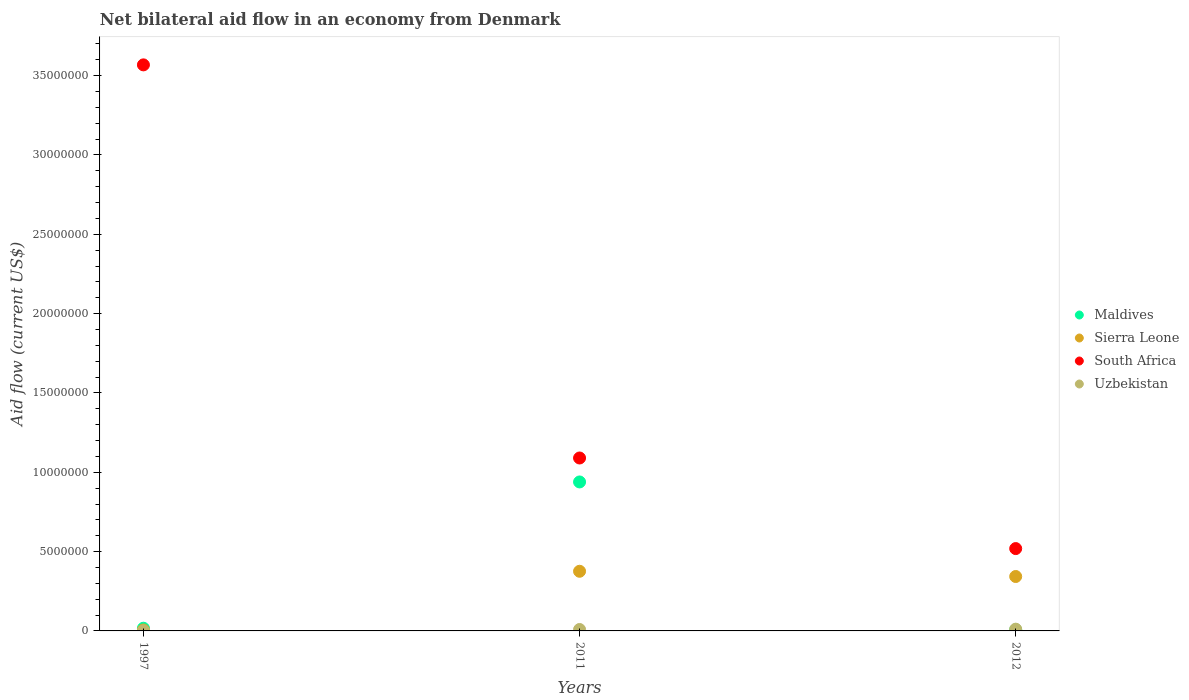Is the number of dotlines equal to the number of legend labels?
Provide a succinct answer. Yes. What is the net bilateral aid flow in South Africa in 2011?
Your answer should be very brief. 1.09e+07. Across all years, what is the maximum net bilateral aid flow in South Africa?
Provide a succinct answer. 3.57e+07. In which year was the net bilateral aid flow in Sierra Leone maximum?
Provide a short and direct response. 2011. In which year was the net bilateral aid flow in South Africa minimum?
Your answer should be compact. 2012. What is the total net bilateral aid flow in Maldives in the graph?
Ensure brevity in your answer.  9.63e+06. What is the difference between the net bilateral aid flow in South Africa in 1997 and that in 2012?
Give a very brief answer. 3.05e+07. What is the difference between the net bilateral aid flow in Sierra Leone in 2011 and the net bilateral aid flow in South Africa in 1997?
Your answer should be compact. -3.19e+07. What is the average net bilateral aid flow in Uzbekistan per year?
Ensure brevity in your answer.  7.00e+04. In the year 1997, what is the difference between the net bilateral aid flow in Maldives and net bilateral aid flow in Uzbekistan?
Provide a short and direct response. 1.60e+05. In how many years, is the net bilateral aid flow in Maldives greater than 7000000 US$?
Your response must be concise. 1. What is the ratio of the net bilateral aid flow in South Africa in 1997 to that in 2011?
Your response must be concise. 3.27. What is the difference between the highest and the second highest net bilateral aid flow in South Africa?
Your answer should be compact. 2.48e+07. What is the difference between the highest and the lowest net bilateral aid flow in Maldives?
Give a very brief answer. 9.32e+06. Is the sum of the net bilateral aid flow in Uzbekistan in 2011 and 2012 greater than the maximum net bilateral aid flow in South Africa across all years?
Offer a terse response. No. Is it the case that in every year, the sum of the net bilateral aid flow in Uzbekistan and net bilateral aid flow in South Africa  is greater than the net bilateral aid flow in Sierra Leone?
Give a very brief answer. Yes. Does the net bilateral aid flow in Maldives monotonically increase over the years?
Offer a very short reply. No. How many dotlines are there?
Make the answer very short. 4. How many years are there in the graph?
Your response must be concise. 3. What is the difference between two consecutive major ticks on the Y-axis?
Provide a short and direct response. 5.00e+06. Does the graph contain any zero values?
Your response must be concise. No. How are the legend labels stacked?
Your response must be concise. Vertical. What is the title of the graph?
Make the answer very short. Net bilateral aid flow in an economy from Denmark. What is the Aid flow (current US$) of Maldives in 1997?
Make the answer very short. 1.70e+05. What is the Aid flow (current US$) of South Africa in 1997?
Provide a short and direct response. 3.57e+07. What is the Aid flow (current US$) in Maldives in 2011?
Give a very brief answer. 9.39e+06. What is the Aid flow (current US$) of Sierra Leone in 2011?
Offer a terse response. 3.76e+06. What is the Aid flow (current US$) of South Africa in 2011?
Offer a very short reply. 1.09e+07. What is the Aid flow (current US$) in Sierra Leone in 2012?
Provide a succinct answer. 3.43e+06. What is the Aid flow (current US$) in South Africa in 2012?
Offer a terse response. 5.19e+06. Across all years, what is the maximum Aid flow (current US$) of Maldives?
Your response must be concise. 9.39e+06. Across all years, what is the maximum Aid flow (current US$) of Sierra Leone?
Offer a terse response. 3.76e+06. Across all years, what is the maximum Aid flow (current US$) in South Africa?
Your answer should be compact. 3.57e+07. Across all years, what is the minimum Aid flow (current US$) in Sierra Leone?
Offer a very short reply. 6.00e+04. Across all years, what is the minimum Aid flow (current US$) of South Africa?
Make the answer very short. 5.19e+06. Across all years, what is the minimum Aid flow (current US$) of Uzbekistan?
Offer a very short reply. 10000. What is the total Aid flow (current US$) in Maldives in the graph?
Your answer should be compact. 9.63e+06. What is the total Aid flow (current US$) in Sierra Leone in the graph?
Make the answer very short. 7.25e+06. What is the total Aid flow (current US$) of South Africa in the graph?
Provide a short and direct response. 5.18e+07. What is the total Aid flow (current US$) in Uzbekistan in the graph?
Provide a short and direct response. 2.10e+05. What is the difference between the Aid flow (current US$) of Maldives in 1997 and that in 2011?
Your answer should be very brief. -9.22e+06. What is the difference between the Aid flow (current US$) of Sierra Leone in 1997 and that in 2011?
Provide a short and direct response. -3.70e+06. What is the difference between the Aid flow (current US$) in South Africa in 1997 and that in 2011?
Offer a terse response. 2.48e+07. What is the difference between the Aid flow (current US$) in Uzbekistan in 1997 and that in 2011?
Make the answer very short. -8.00e+04. What is the difference between the Aid flow (current US$) in Maldives in 1997 and that in 2012?
Offer a very short reply. 1.00e+05. What is the difference between the Aid flow (current US$) of Sierra Leone in 1997 and that in 2012?
Ensure brevity in your answer.  -3.37e+06. What is the difference between the Aid flow (current US$) in South Africa in 1997 and that in 2012?
Make the answer very short. 3.05e+07. What is the difference between the Aid flow (current US$) of Uzbekistan in 1997 and that in 2012?
Offer a very short reply. -1.00e+05. What is the difference between the Aid flow (current US$) in Maldives in 2011 and that in 2012?
Your answer should be compact. 9.32e+06. What is the difference between the Aid flow (current US$) in Sierra Leone in 2011 and that in 2012?
Keep it short and to the point. 3.30e+05. What is the difference between the Aid flow (current US$) in South Africa in 2011 and that in 2012?
Your answer should be compact. 5.71e+06. What is the difference between the Aid flow (current US$) of Maldives in 1997 and the Aid flow (current US$) of Sierra Leone in 2011?
Offer a very short reply. -3.59e+06. What is the difference between the Aid flow (current US$) in Maldives in 1997 and the Aid flow (current US$) in South Africa in 2011?
Provide a succinct answer. -1.07e+07. What is the difference between the Aid flow (current US$) in Sierra Leone in 1997 and the Aid flow (current US$) in South Africa in 2011?
Keep it short and to the point. -1.08e+07. What is the difference between the Aid flow (current US$) in South Africa in 1997 and the Aid flow (current US$) in Uzbekistan in 2011?
Your answer should be very brief. 3.56e+07. What is the difference between the Aid flow (current US$) in Maldives in 1997 and the Aid flow (current US$) in Sierra Leone in 2012?
Keep it short and to the point. -3.26e+06. What is the difference between the Aid flow (current US$) of Maldives in 1997 and the Aid flow (current US$) of South Africa in 2012?
Ensure brevity in your answer.  -5.02e+06. What is the difference between the Aid flow (current US$) in Sierra Leone in 1997 and the Aid flow (current US$) in South Africa in 2012?
Ensure brevity in your answer.  -5.13e+06. What is the difference between the Aid flow (current US$) of Sierra Leone in 1997 and the Aid flow (current US$) of Uzbekistan in 2012?
Offer a very short reply. -5.00e+04. What is the difference between the Aid flow (current US$) in South Africa in 1997 and the Aid flow (current US$) in Uzbekistan in 2012?
Your answer should be very brief. 3.56e+07. What is the difference between the Aid flow (current US$) of Maldives in 2011 and the Aid flow (current US$) of Sierra Leone in 2012?
Provide a short and direct response. 5.96e+06. What is the difference between the Aid flow (current US$) of Maldives in 2011 and the Aid flow (current US$) of South Africa in 2012?
Make the answer very short. 4.20e+06. What is the difference between the Aid flow (current US$) of Maldives in 2011 and the Aid flow (current US$) of Uzbekistan in 2012?
Provide a short and direct response. 9.28e+06. What is the difference between the Aid flow (current US$) in Sierra Leone in 2011 and the Aid flow (current US$) in South Africa in 2012?
Provide a short and direct response. -1.43e+06. What is the difference between the Aid flow (current US$) in Sierra Leone in 2011 and the Aid flow (current US$) in Uzbekistan in 2012?
Offer a terse response. 3.65e+06. What is the difference between the Aid flow (current US$) of South Africa in 2011 and the Aid flow (current US$) of Uzbekistan in 2012?
Your answer should be very brief. 1.08e+07. What is the average Aid flow (current US$) in Maldives per year?
Your answer should be compact. 3.21e+06. What is the average Aid flow (current US$) in Sierra Leone per year?
Provide a short and direct response. 2.42e+06. What is the average Aid flow (current US$) of South Africa per year?
Provide a succinct answer. 1.73e+07. In the year 1997, what is the difference between the Aid flow (current US$) in Maldives and Aid flow (current US$) in South Africa?
Ensure brevity in your answer.  -3.55e+07. In the year 1997, what is the difference between the Aid flow (current US$) in Maldives and Aid flow (current US$) in Uzbekistan?
Provide a succinct answer. 1.60e+05. In the year 1997, what is the difference between the Aid flow (current US$) in Sierra Leone and Aid flow (current US$) in South Africa?
Provide a short and direct response. -3.56e+07. In the year 1997, what is the difference between the Aid flow (current US$) in Sierra Leone and Aid flow (current US$) in Uzbekistan?
Your answer should be very brief. 5.00e+04. In the year 1997, what is the difference between the Aid flow (current US$) in South Africa and Aid flow (current US$) in Uzbekistan?
Give a very brief answer. 3.57e+07. In the year 2011, what is the difference between the Aid flow (current US$) of Maldives and Aid flow (current US$) of Sierra Leone?
Give a very brief answer. 5.63e+06. In the year 2011, what is the difference between the Aid flow (current US$) of Maldives and Aid flow (current US$) of South Africa?
Keep it short and to the point. -1.51e+06. In the year 2011, what is the difference between the Aid flow (current US$) in Maldives and Aid flow (current US$) in Uzbekistan?
Your answer should be very brief. 9.30e+06. In the year 2011, what is the difference between the Aid flow (current US$) of Sierra Leone and Aid flow (current US$) of South Africa?
Offer a terse response. -7.14e+06. In the year 2011, what is the difference between the Aid flow (current US$) in Sierra Leone and Aid flow (current US$) in Uzbekistan?
Your answer should be compact. 3.67e+06. In the year 2011, what is the difference between the Aid flow (current US$) in South Africa and Aid flow (current US$) in Uzbekistan?
Provide a short and direct response. 1.08e+07. In the year 2012, what is the difference between the Aid flow (current US$) in Maldives and Aid flow (current US$) in Sierra Leone?
Give a very brief answer. -3.36e+06. In the year 2012, what is the difference between the Aid flow (current US$) in Maldives and Aid flow (current US$) in South Africa?
Give a very brief answer. -5.12e+06. In the year 2012, what is the difference between the Aid flow (current US$) of Sierra Leone and Aid flow (current US$) of South Africa?
Your response must be concise. -1.76e+06. In the year 2012, what is the difference between the Aid flow (current US$) of Sierra Leone and Aid flow (current US$) of Uzbekistan?
Make the answer very short. 3.32e+06. In the year 2012, what is the difference between the Aid flow (current US$) in South Africa and Aid flow (current US$) in Uzbekistan?
Your answer should be very brief. 5.08e+06. What is the ratio of the Aid flow (current US$) in Maldives in 1997 to that in 2011?
Provide a short and direct response. 0.02. What is the ratio of the Aid flow (current US$) of Sierra Leone in 1997 to that in 2011?
Keep it short and to the point. 0.02. What is the ratio of the Aid flow (current US$) in South Africa in 1997 to that in 2011?
Ensure brevity in your answer.  3.27. What is the ratio of the Aid flow (current US$) of Uzbekistan in 1997 to that in 2011?
Your response must be concise. 0.11. What is the ratio of the Aid flow (current US$) of Maldives in 1997 to that in 2012?
Your answer should be very brief. 2.43. What is the ratio of the Aid flow (current US$) in Sierra Leone in 1997 to that in 2012?
Provide a short and direct response. 0.02. What is the ratio of the Aid flow (current US$) in South Africa in 1997 to that in 2012?
Your answer should be compact. 6.87. What is the ratio of the Aid flow (current US$) in Uzbekistan in 1997 to that in 2012?
Keep it short and to the point. 0.09. What is the ratio of the Aid flow (current US$) of Maldives in 2011 to that in 2012?
Ensure brevity in your answer.  134.14. What is the ratio of the Aid flow (current US$) of Sierra Leone in 2011 to that in 2012?
Your answer should be very brief. 1.1. What is the ratio of the Aid flow (current US$) of South Africa in 2011 to that in 2012?
Offer a very short reply. 2.1. What is the ratio of the Aid flow (current US$) of Uzbekistan in 2011 to that in 2012?
Make the answer very short. 0.82. What is the difference between the highest and the second highest Aid flow (current US$) in Maldives?
Provide a succinct answer. 9.22e+06. What is the difference between the highest and the second highest Aid flow (current US$) of Sierra Leone?
Ensure brevity in your answer.  3.30e+05. What is the difference between the highest and the second highest Aid flow (current US$) of South Africa?
Provide a short and direct response. 2.48e+07. What is the difference between the highest and the second highest Aid flow (current US$) in Uzbekistan?
Make the answer very short. 2.00e+04. What is the difference between the highest and the lowest Aid flow (current US$) in Maldives?
Provide a succinct answer. 9.32e+06. What is the difference between the highest and the lowest Aid flow (current US$) of Sierra Leone?
Your response must be concise. 3.70e+06. What is the difference between the highest and the lowest Aid flow (current US$) in South Africa?
Give a very brief answer. 3.05e+07. What is the difference between the highest and the lowest Aid flow (current US$) in Uzbekistan?
Provide a short and direct response. 1.00e+05. 